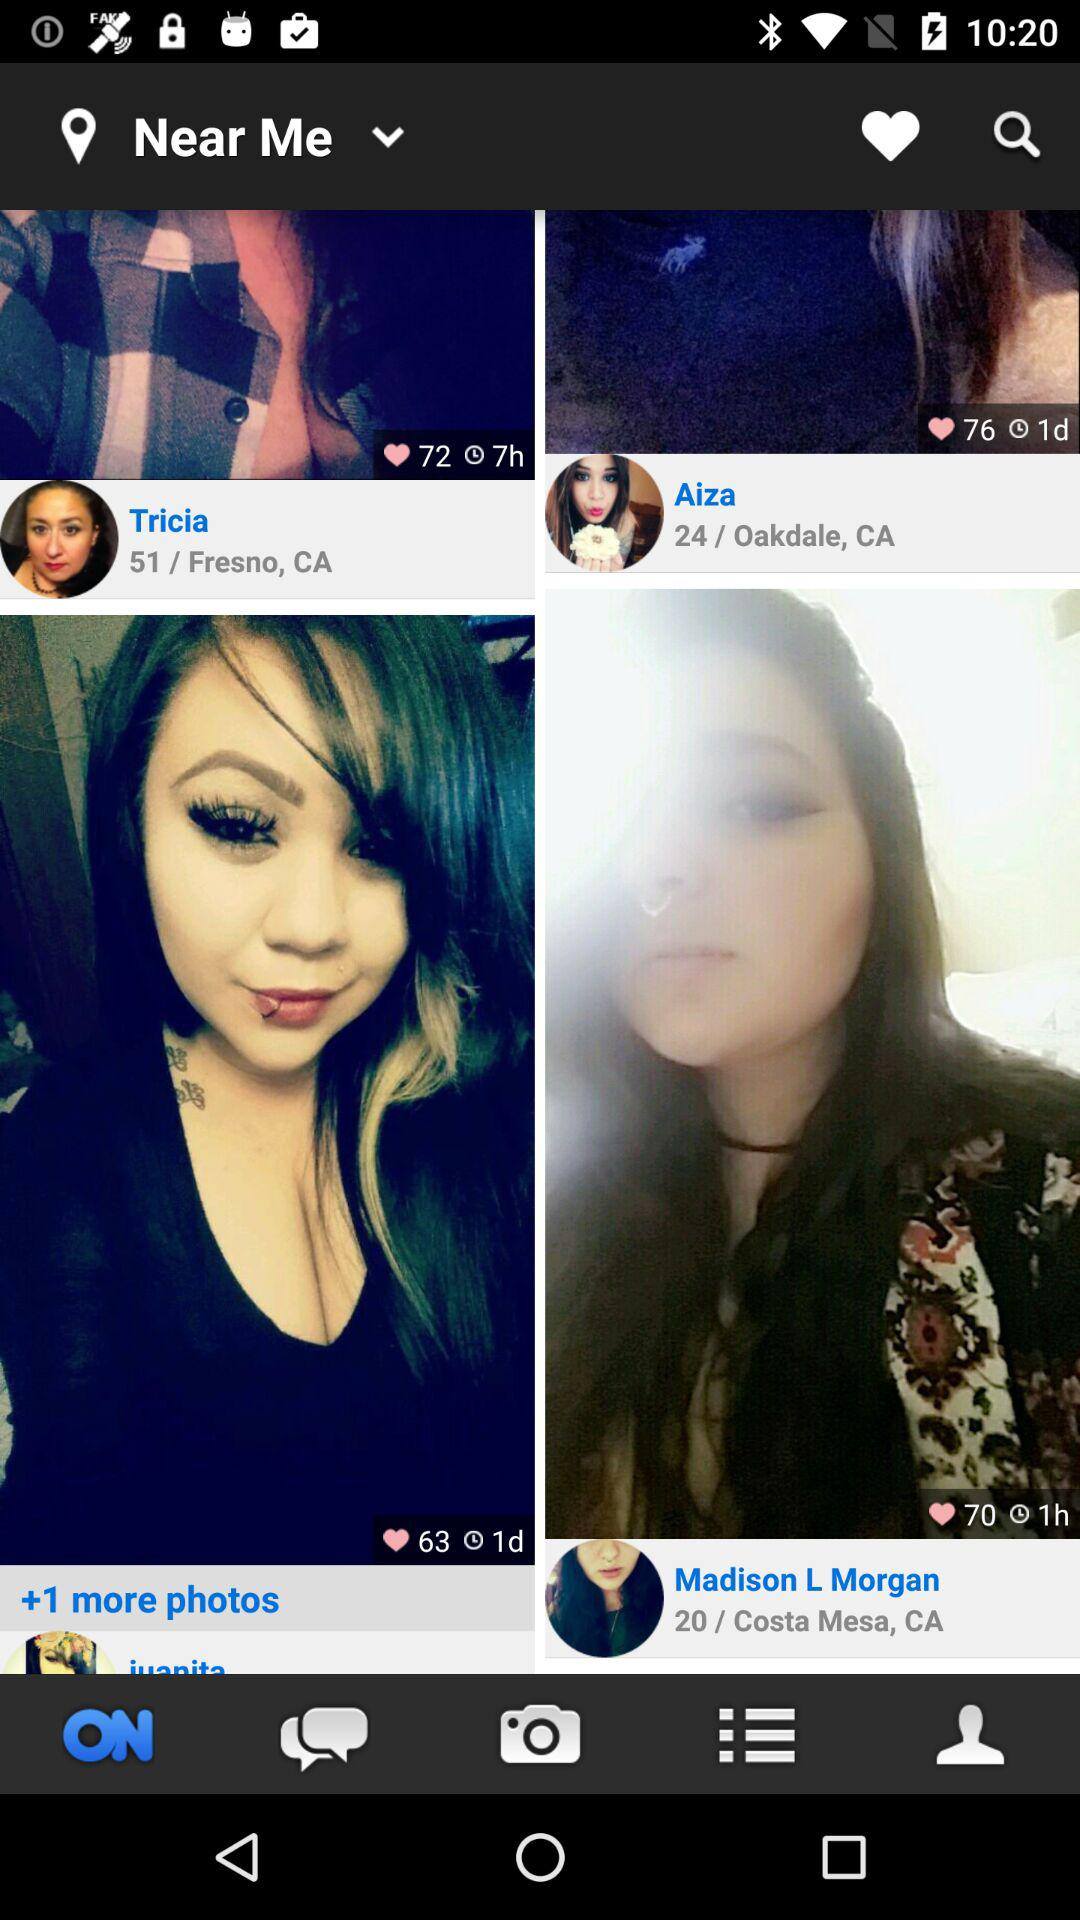What is the location of Aiza? The location of Aiza is 24/Oakdale, CA. 